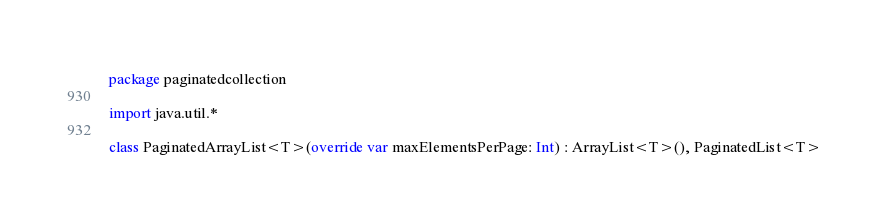<code> <loc_0><loc_0><loc_500><loc_500><_Kotlin_>package paginatedcollection

import java.util.*

class PaginatedArrayList<T>(override var maxElementsPerPage: Int) : ArrayList<T>(), PaginatedList<T></code> 